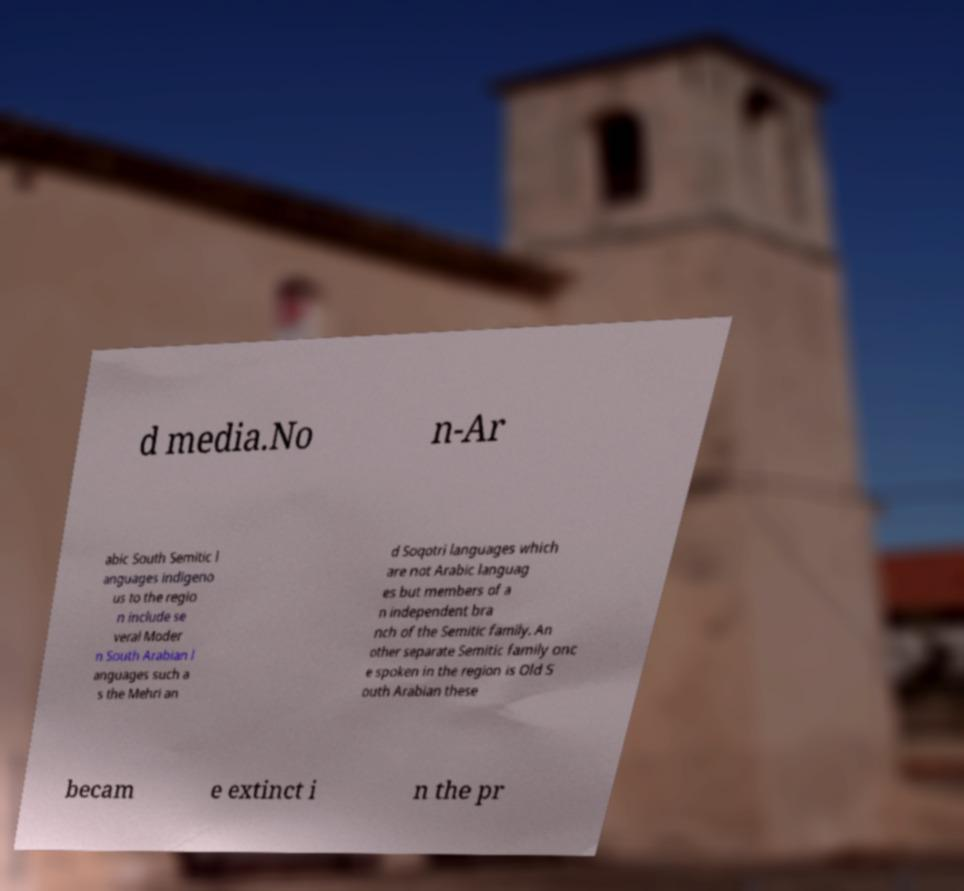There's text embedded in this image that I need extracted. Can you transcribe it verbatim? d media.No n-Ar abic South Semitic l anguages indigeno us to the regio n include se veral Moder n South Arabian l anguages such a s the Mehri an d Soqotri languages which are not Arabic languag es but members of a n independent bra nch of the Semitic family. An other separate Semitic family onc e spoken in the region is Old S outh Arabian these becam e extinct i n the pr 